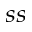<formula> <loc_0><loc_0><loc_500><loc_500>_ { s s }</formula> 